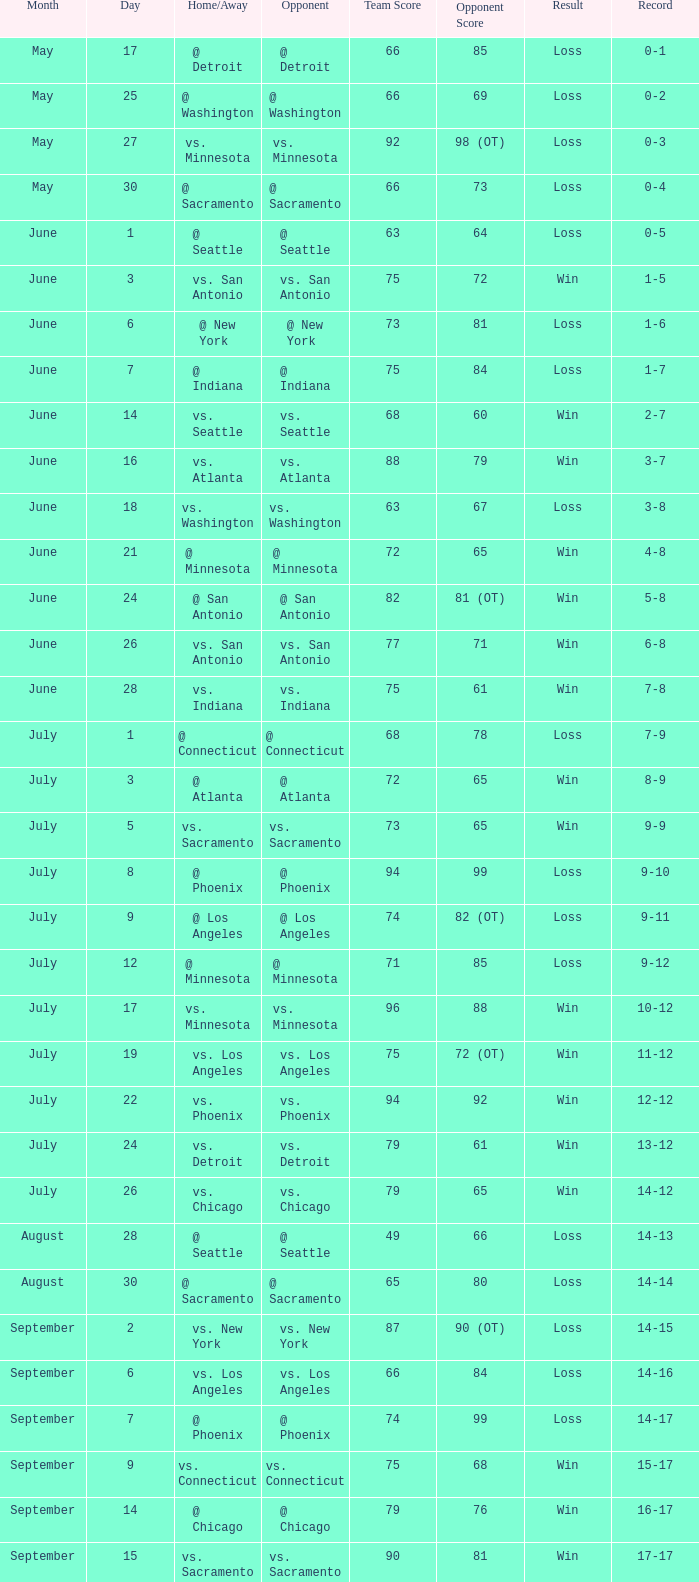What is the Date of the game with a Loss and Record of 7-9? July 1. 